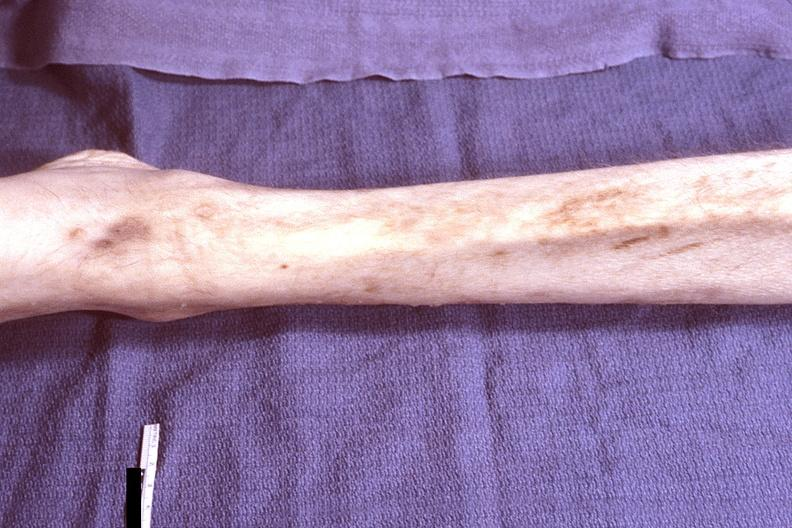what is present?
Answer the question using a single word or phrase. Musculoskeletal 